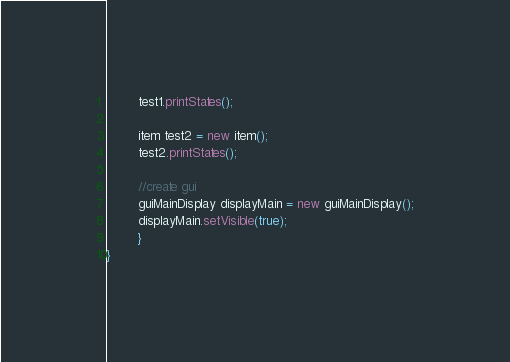<code> <loc_0><loc_0><loc_500><loc_500><_Java_>        test1.printStates();
        
        item test2 = new item();
        test2.printStates();
        
        //create gui
        guiMainDisplay displayMain = new guiMainDisplay();
        displayMain.setVisible(true);
        }
}
</code> 